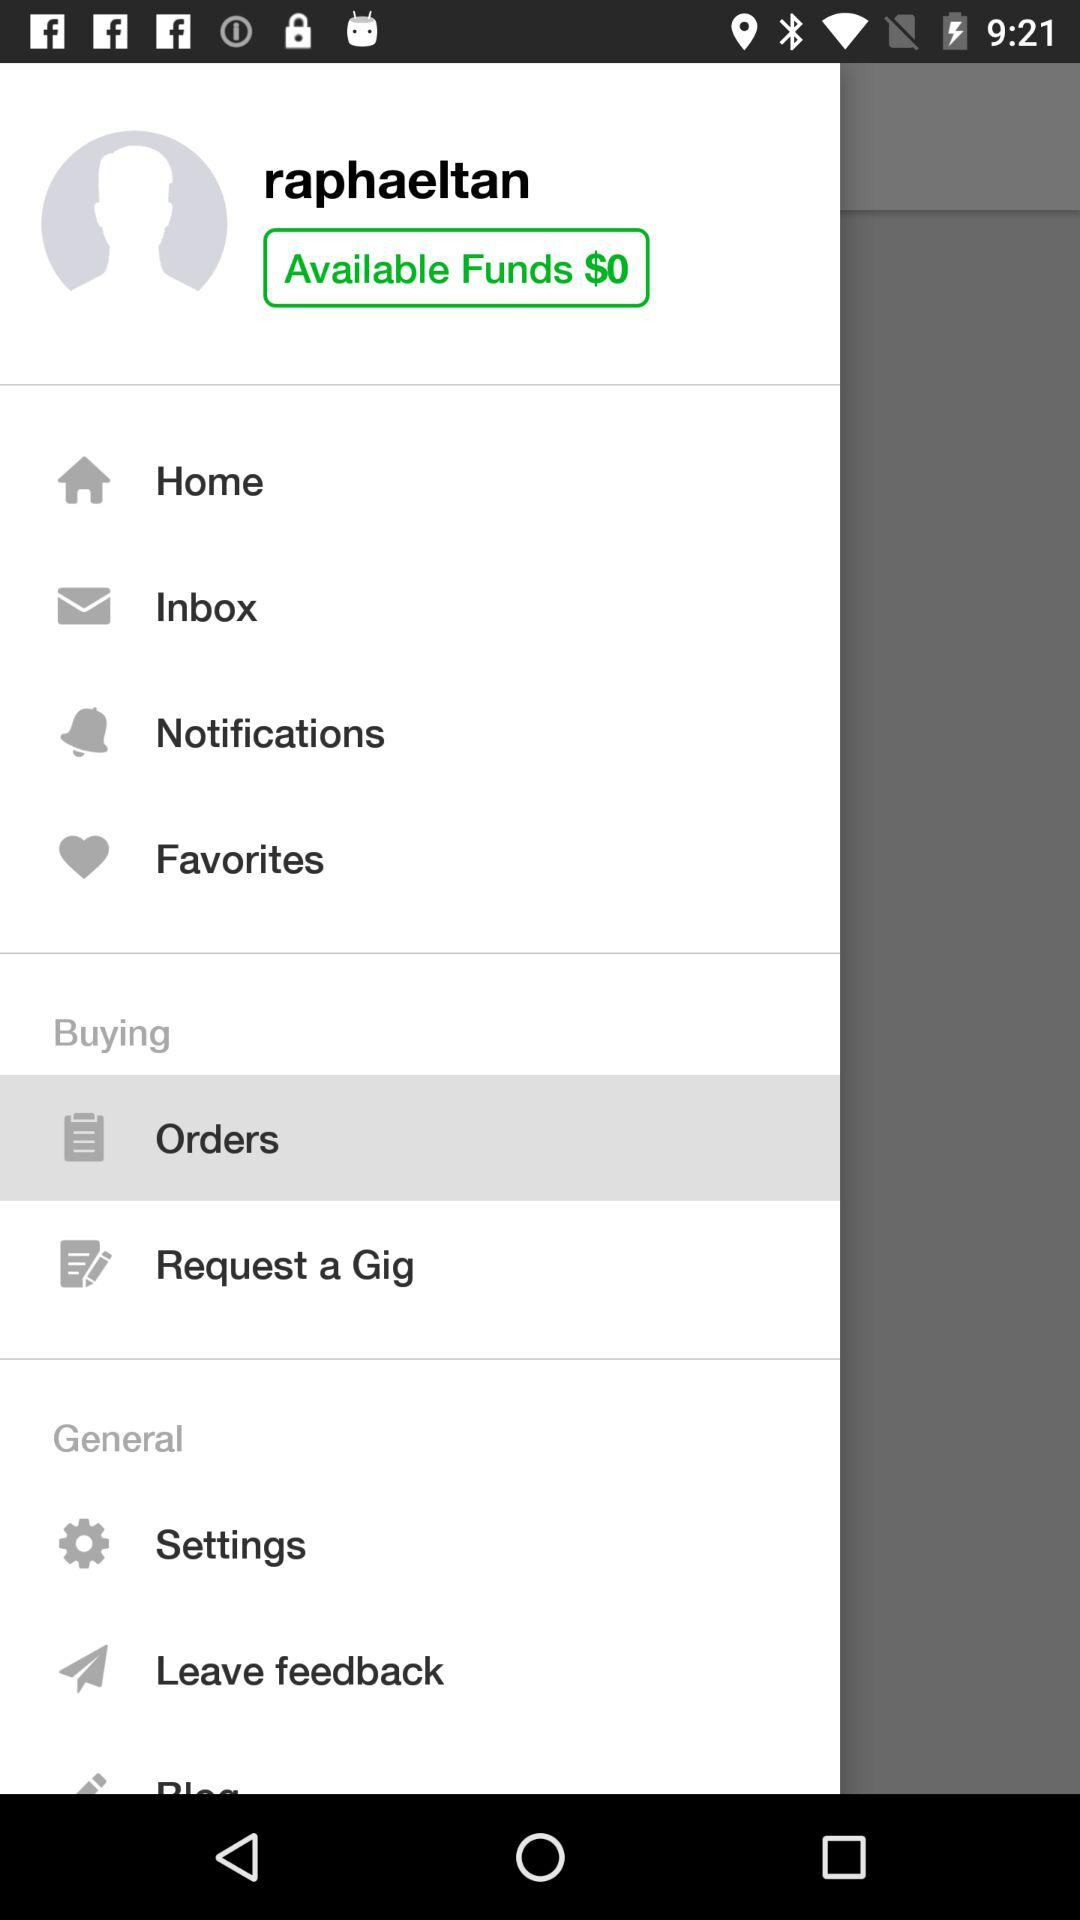How much money do I have in my account?
Answer the question using a single word or phrase. $0 